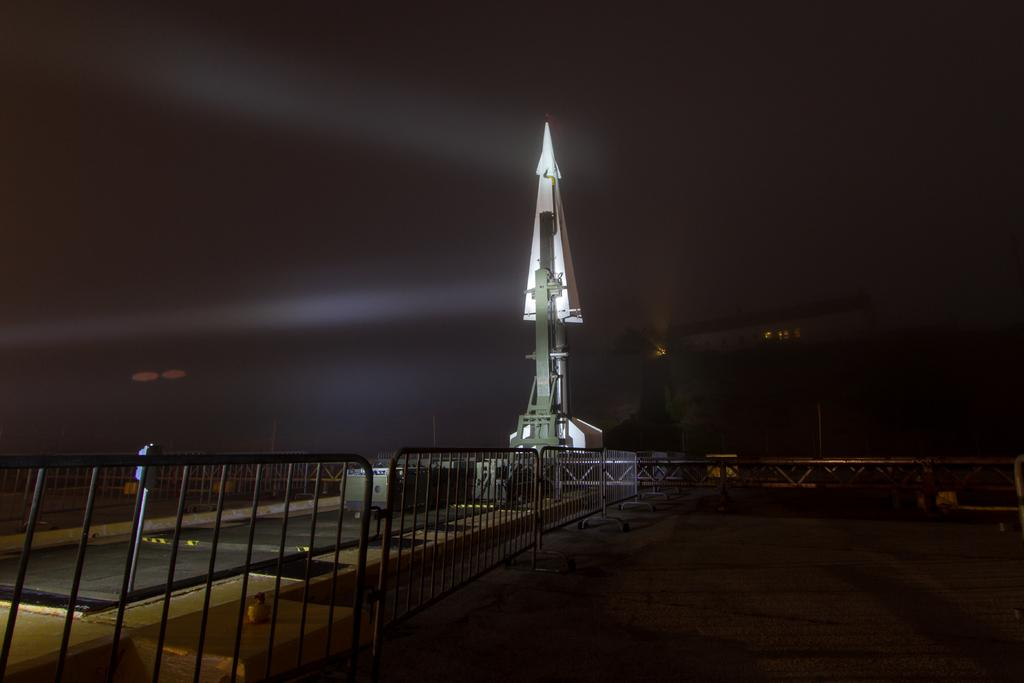What is the main subject of the image? The main subject of the image is a rocket. What else can be seen in the image besides the rocket? There is a fencing in the image. What type of humor can be seen in the image? There is no humor present in the image; it features a rocket and fencing. What is the rhythm of the rocket in the image? The rocket in the image is stationary and not moving, so there is no rhythm associated with it. 